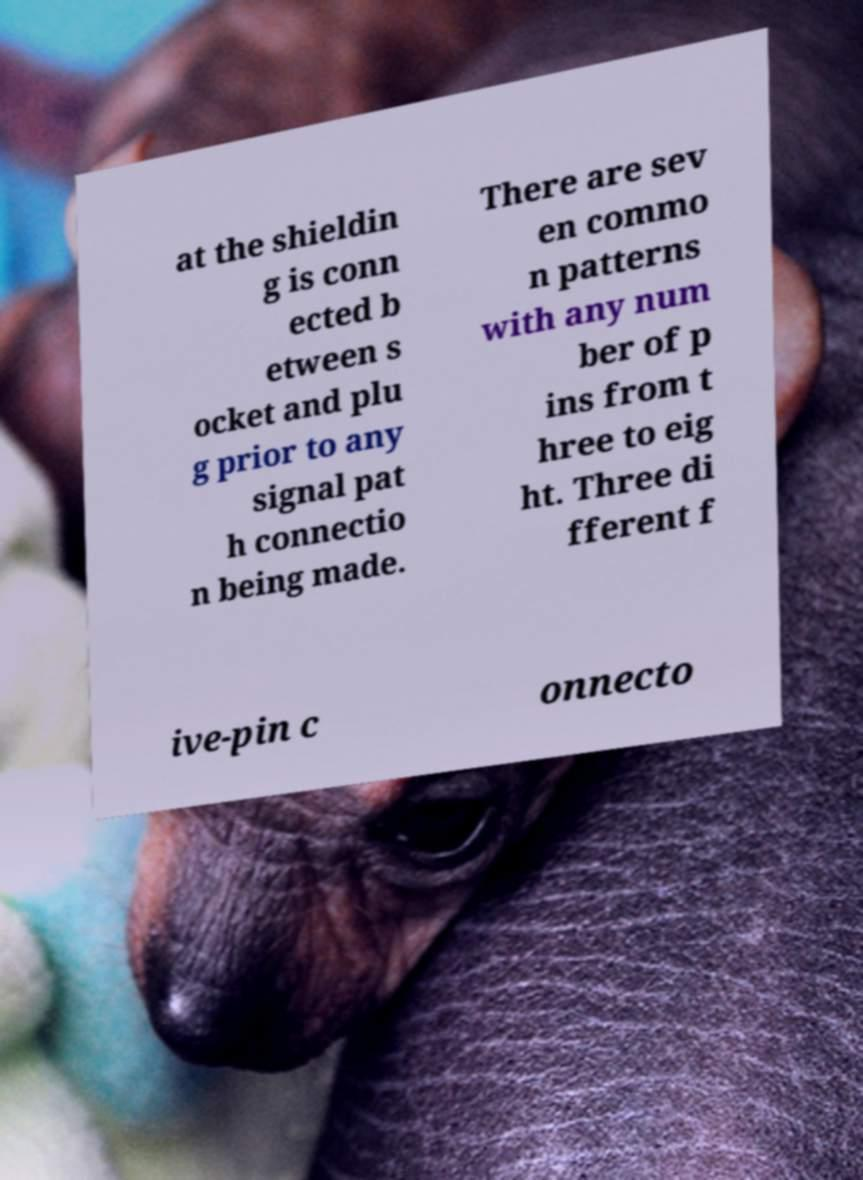Can you accurately transcribe the text from the provided image for me? at the shieldin g is conn ected b etween s ocket and plu g prior to any signal pat h connectio n being made. There are sev en commo n patterns with any num ber of p ins from t hree to eig ht. Three di fferent f ive-pin c onnecto 